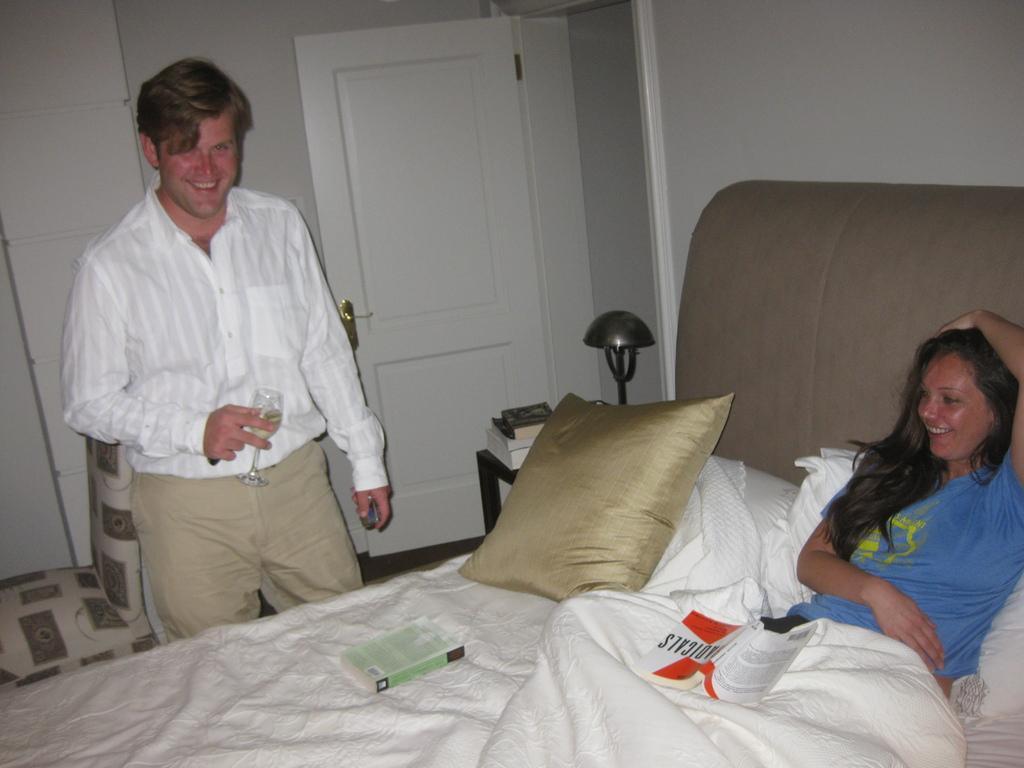Describe this image in one or two sentences. In this image there is a man who is standing with a glass in his hand. In the middle their is woman who is sleeping on the bed,on the bed there is pillow,bed sheet and the book. At the background there is door,table and chair. 